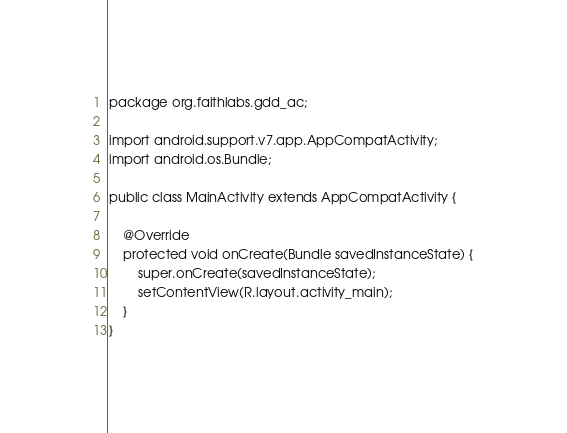Convert code to text. <code><loc_0><loc_0><loc_500><loc_500><_Java_>package org.faithlabs.gdd_ac;

import android.support.v7.app.AppCompatActivity;
import android.os.Bundle;

public class MainActivity extends AppCompatActivity {

    @Override
    protected void onCreate(Bundle savedInstanceState) {
        super.onCreate(savedInstanceState);
        setContentView(R.layout.activity_main);
    }
}
</code> 